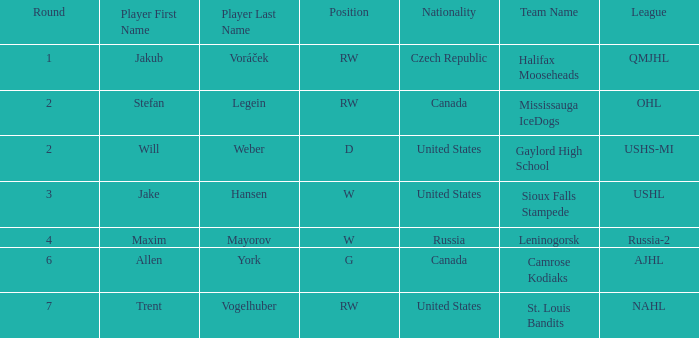What nationality is the draft pick with w position from leninogorsk (russia-2)? Russia. 